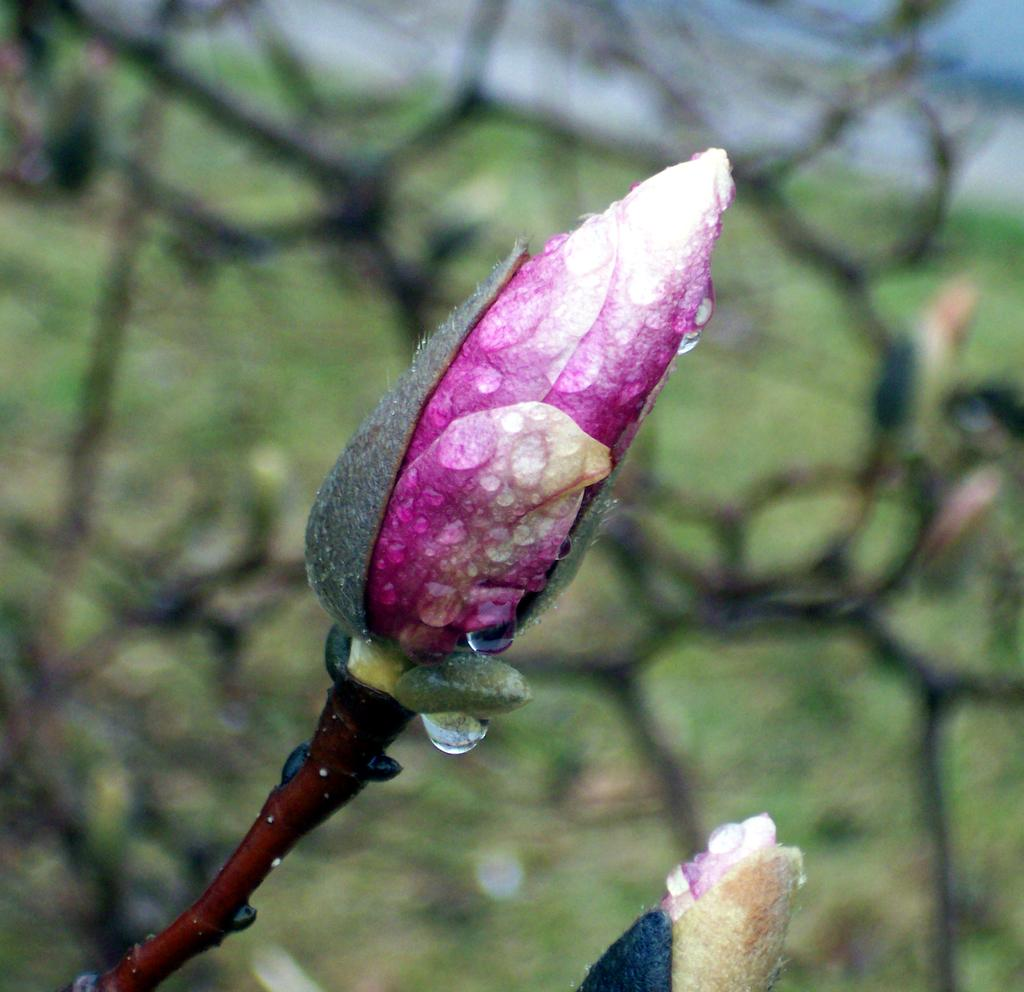What type of plant can be seen in the image? There is a plant in the image. What color is the flower on the plant? There is a flower in pink color in the image. What can be seen on the ground in the background of the image? There is green grass on the ground in the background of the image. How would you describe the background of the image? The background of the image is blurred. How does the plant control the growth of the flower in the image? The plant does not control the growth of the flower in the image; the growth is a natural process. 